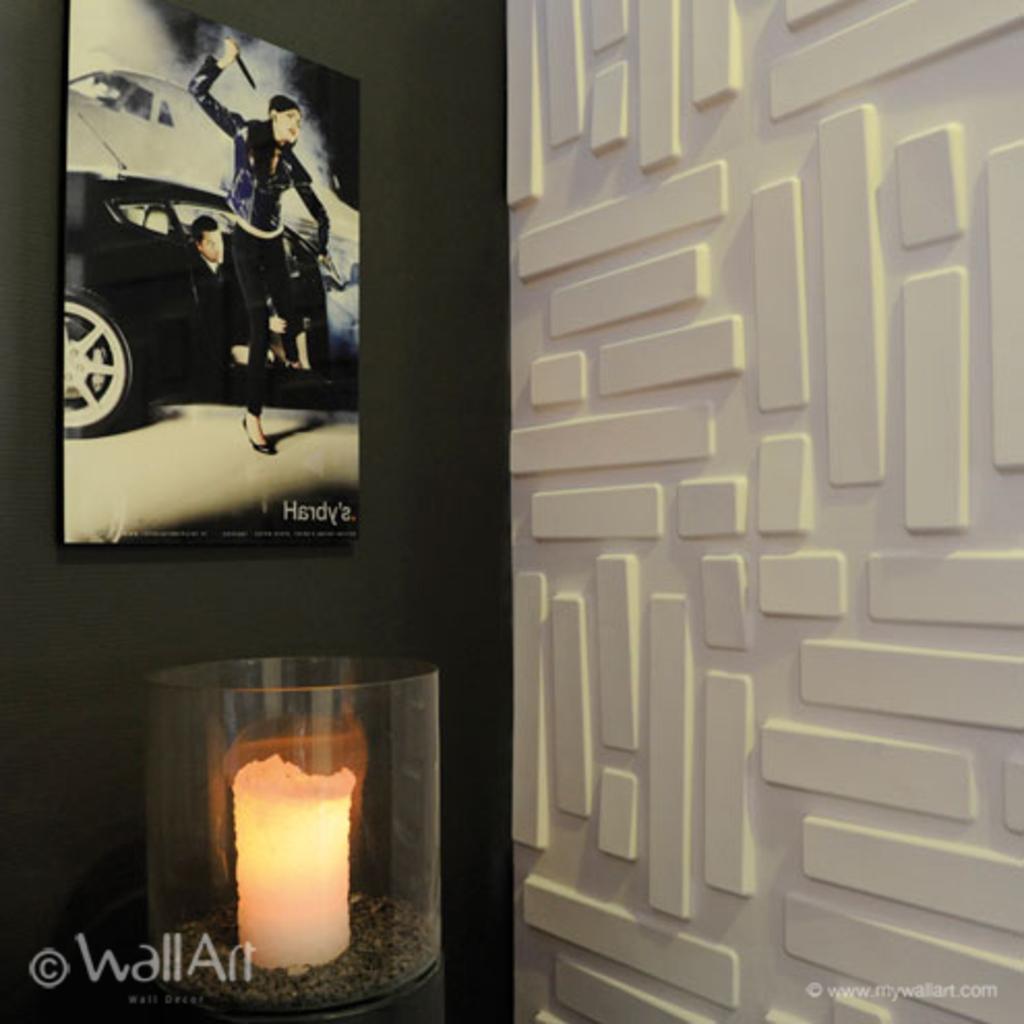Please provide a concise description of this image. In this image there is an object , frame attached to the wall, design on the wall, and there are watermarks on the image. 